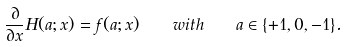Convert formula to latex. <formula><loc_0><loc_0><loc_500><loc_500>\frac { \partial } { \partial x } H ( a ; x ) = f ( a ; x ) \quad w i t h \quad a \in \{ + 1 , 0 , - 1 \} .</formula> 